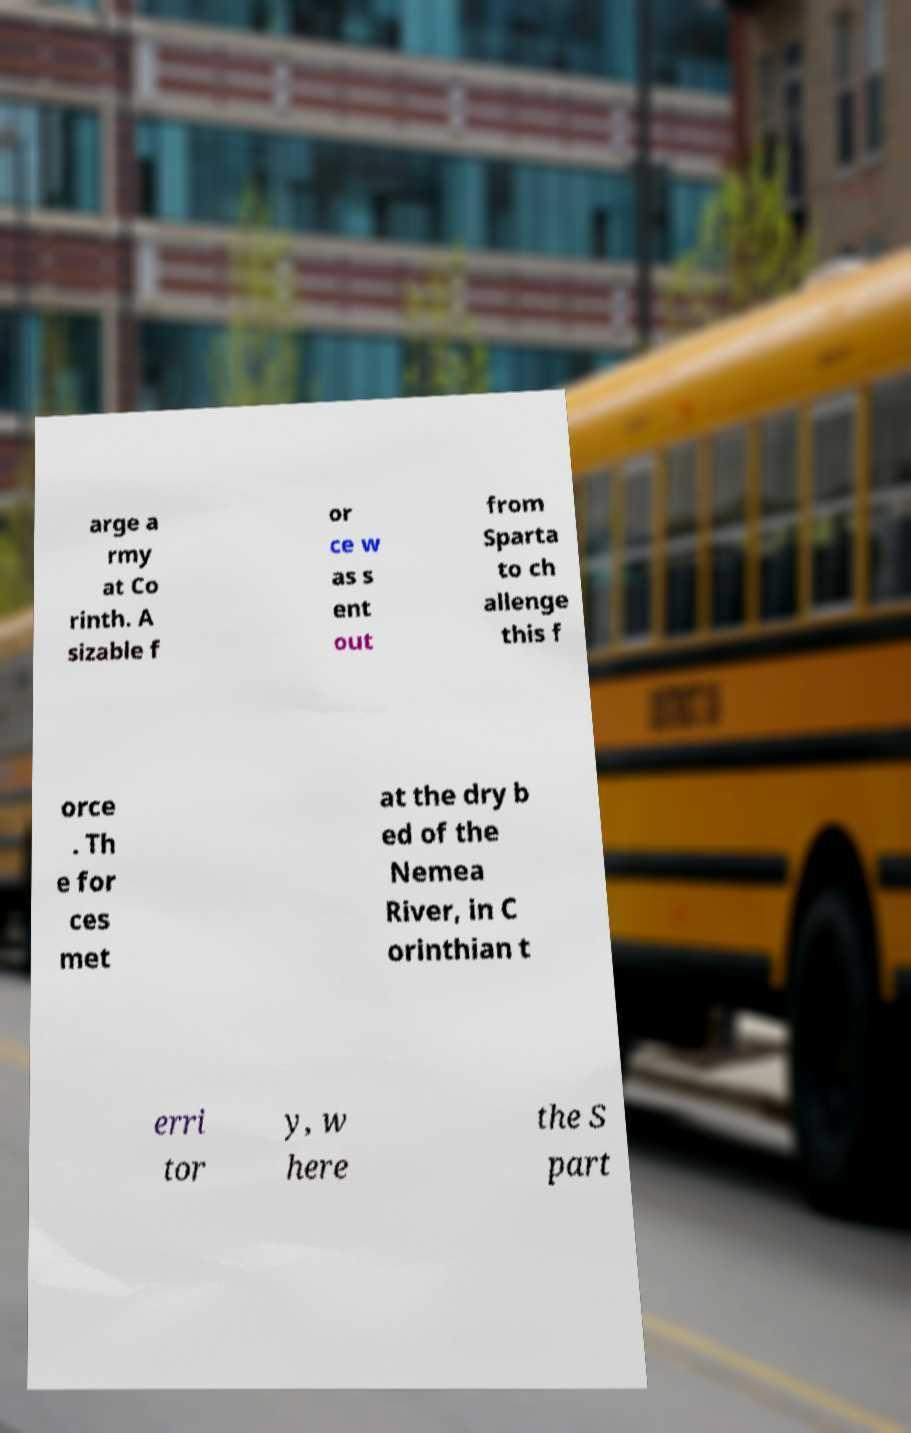Could you extract and type out the text from this image? arge a rmy at Co rinth. A sizable f or ce w as s ent out from Sparta to ch allenge this f orce . Th e for ces met at the dry b ed of the Nemea River, in C orinthian t erri tor y, w here the S part 